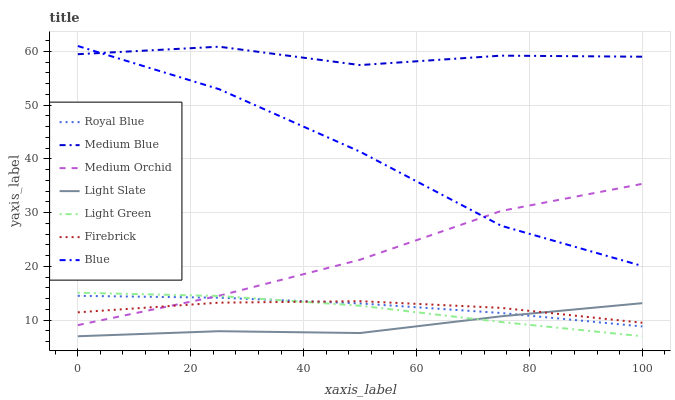Does Light Slate have the minimum area under the curve?
Answer yes or no. Yes. Does Medium Blue have the maximum area under the curve?
Answer yes or no. Yes. Does Firebrick have the minimum area under the curve?
Answer yes or no. No. Does Firebrick have the maximum area under the curve?
Answer yes or no. No. Is Royal Blue the smoothest?
Answer yes or no. Yes. Is Blue the roughest?
Answer yes or no. Yes. Is Light Slate the smoothest?
Answer yes or no. No. Is Light Slate the roughest?
Answer yes or no. No. Does Light Slate have the lowest value?
Answer yes or no. Yes. Does Firebrick have the lowest value?
Answer yes or no. No. Does Blue have the highest value?
Answer yes or no. Yes. Does Firebrick have the highest value?
Answer yes or no. No. Is Light Green less than Blue?
Answer yes or no. Yes. Is Medium Blue greater than Firebrick?
Answer yes or no. Yes. Does Firebrick intersect Light Slate?
Answer yes or no. Yes. Is Firebrick less than Light Slate?
Answer yes or no. No. Is Firebrick greater than Light Slate?
Answer yes or no. No. Does Light Green intersect Blue?
Answer yes or no. No. 